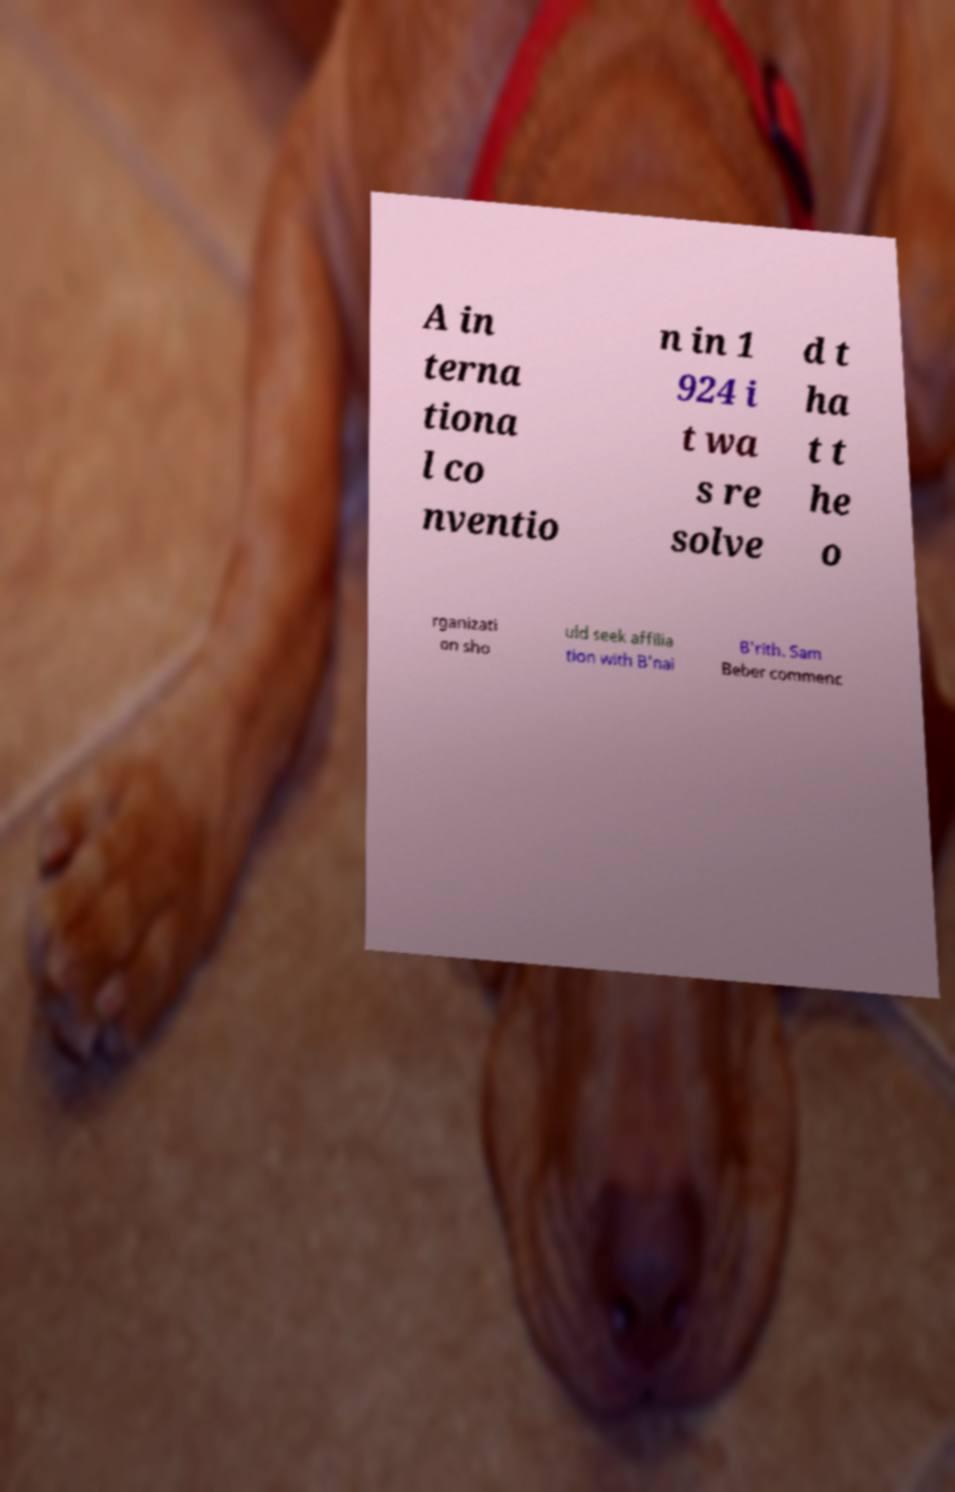Can you read and provide the text displayed in the image?This photo seems to have some interesting text. Can you extract and type it out for me? A in terna tiona l co nventio n in 1 924 i t wa s re solve d t ha t t he o rganizati on sho uld seek affilia tion with B'nai B'rith. Sam Beber commenc 